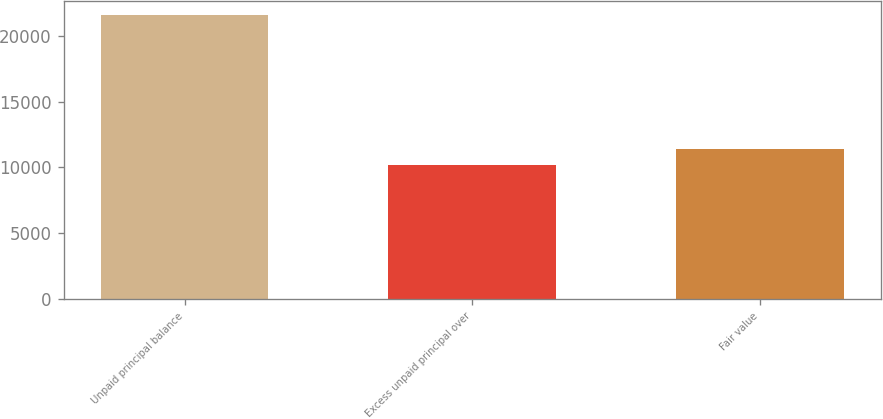<chart> <loc_0><loc_0><loc_500><loc_500><bar_chart><fcel>Unpaid principal balance<fcel>Excess unpaid principal over<fcel>Fair value<nl><fcel>21577<fcel>10178<fcel>11399<nl></chart> 